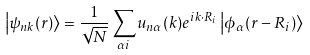Convert formula to latex. <formula><loc_0><loc_0><loc_500><loc_500>\left | \psi _ { n k } ( r ) \right \rangle = \frac { 1 } { \sqrt { N } } \sum _ { \alpha i } u _ { n \alpha } ( k ) e ^ { i k \cdot R _ { i } } \left | \phi _ { \alpha } ( r - R _ { i } ) \right \rangle</formula> 